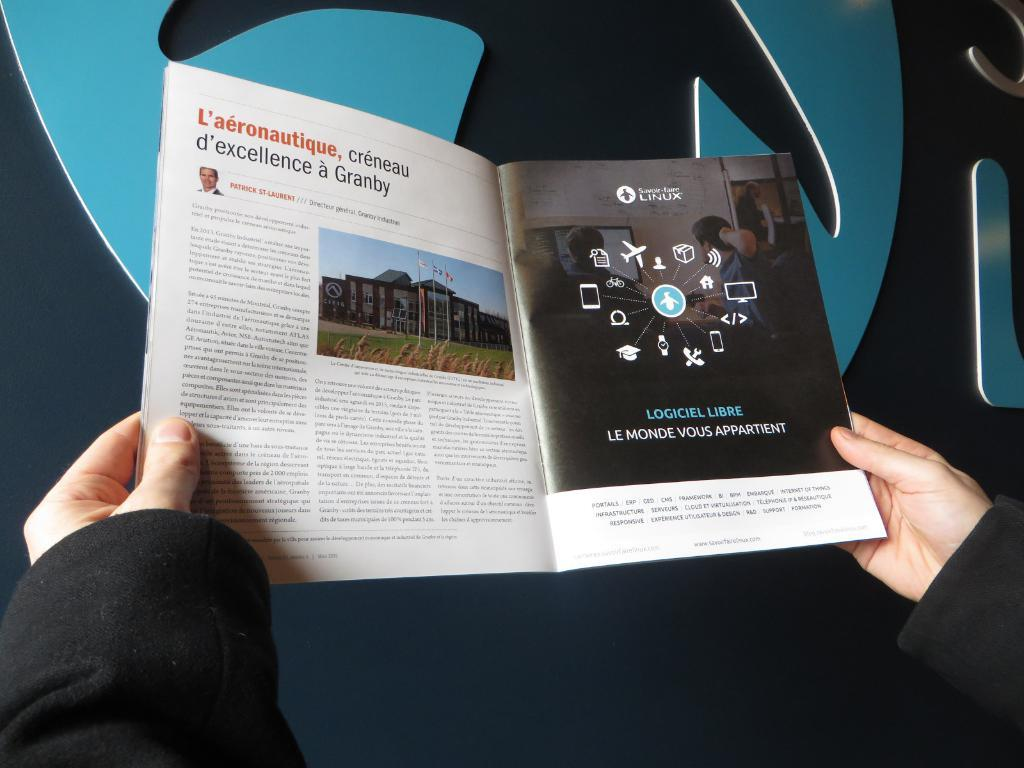<image>
Render a clear and concise summary of the photo. A person reads through a French aeronautical magazine as seen from their perspective. 